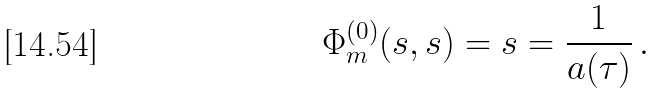Convert formula to latex. <formula><loc_0><loc_0><loc_500><loc_500>\Phi _ { m } ^ { ( 0 ) } ( s , s ) = s = \frac { 1 } { a ( \tau ) } \, .</formula> 